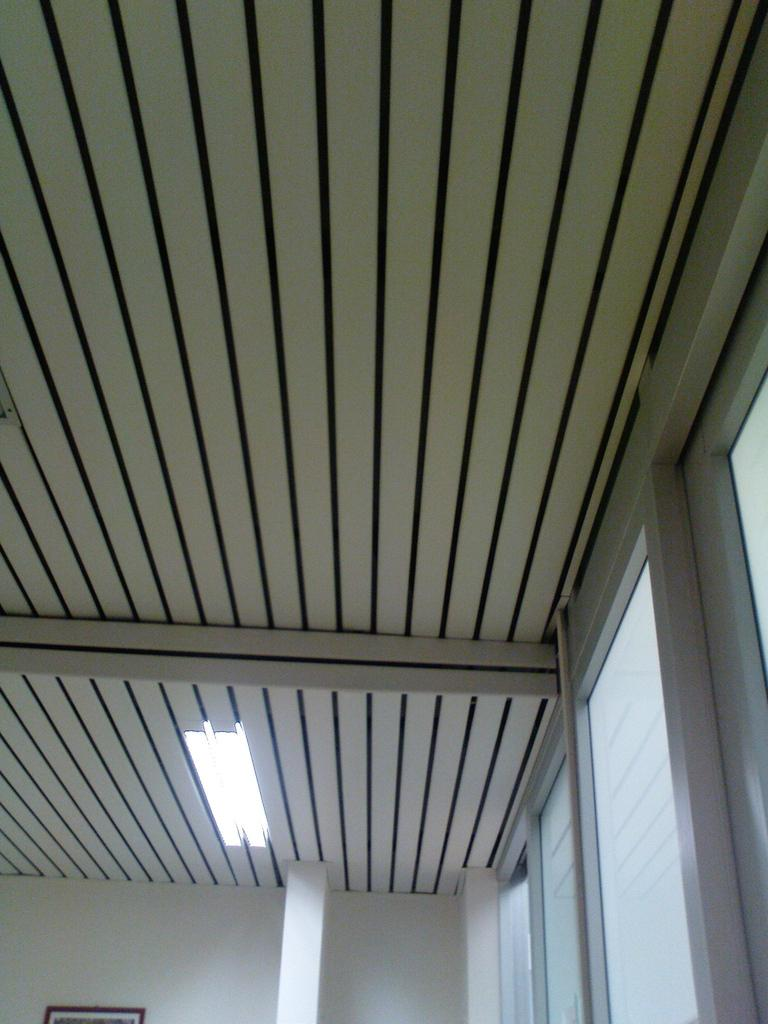Where is the image taken? The image is taken inside a room. What can be seen on the right side of the room? There are windows on the right side of the room. What objects are present in the room? There are glasses, lights, a roof, a photo frame, a pillar, and a wall in the room. What type of church can be seen in the image? There is no church present in the image; it is taken inside a room. How deep is the hole in the room? There is no hole present in the room; the image only shows the features mentioned in the facts. 